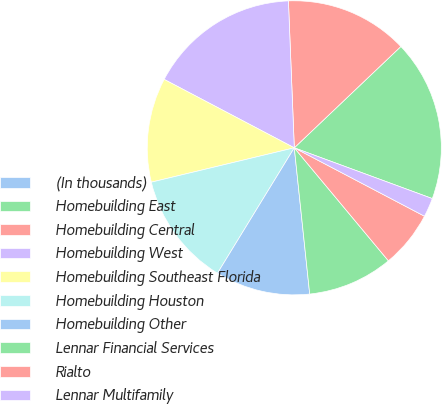Convert chart. <chart><loc_0><loc_0><loc_500><loc_500><pie_chart><fcel>(In thousands)<fcel>Homebuilding East<fcel>Homebuilding Central<fcel>Homebuilding West<fcel>Homebuilding Southeast Florida<fcel>Homebuilding Houston<fcel>Homebuilding Other<fcel>Lennar Financial Services<fcel>Rialto<fcel>Lennar Multifamily<nl><fcel>0.0%<fcel>17.71%<fcel>13.54%<fcel>16.66%<fcel>11.46%<fcel>12.5%<fcel>10.42%<fcel>9.38%<fcel>6.25%<fcel>2.09%<nl></chart> 